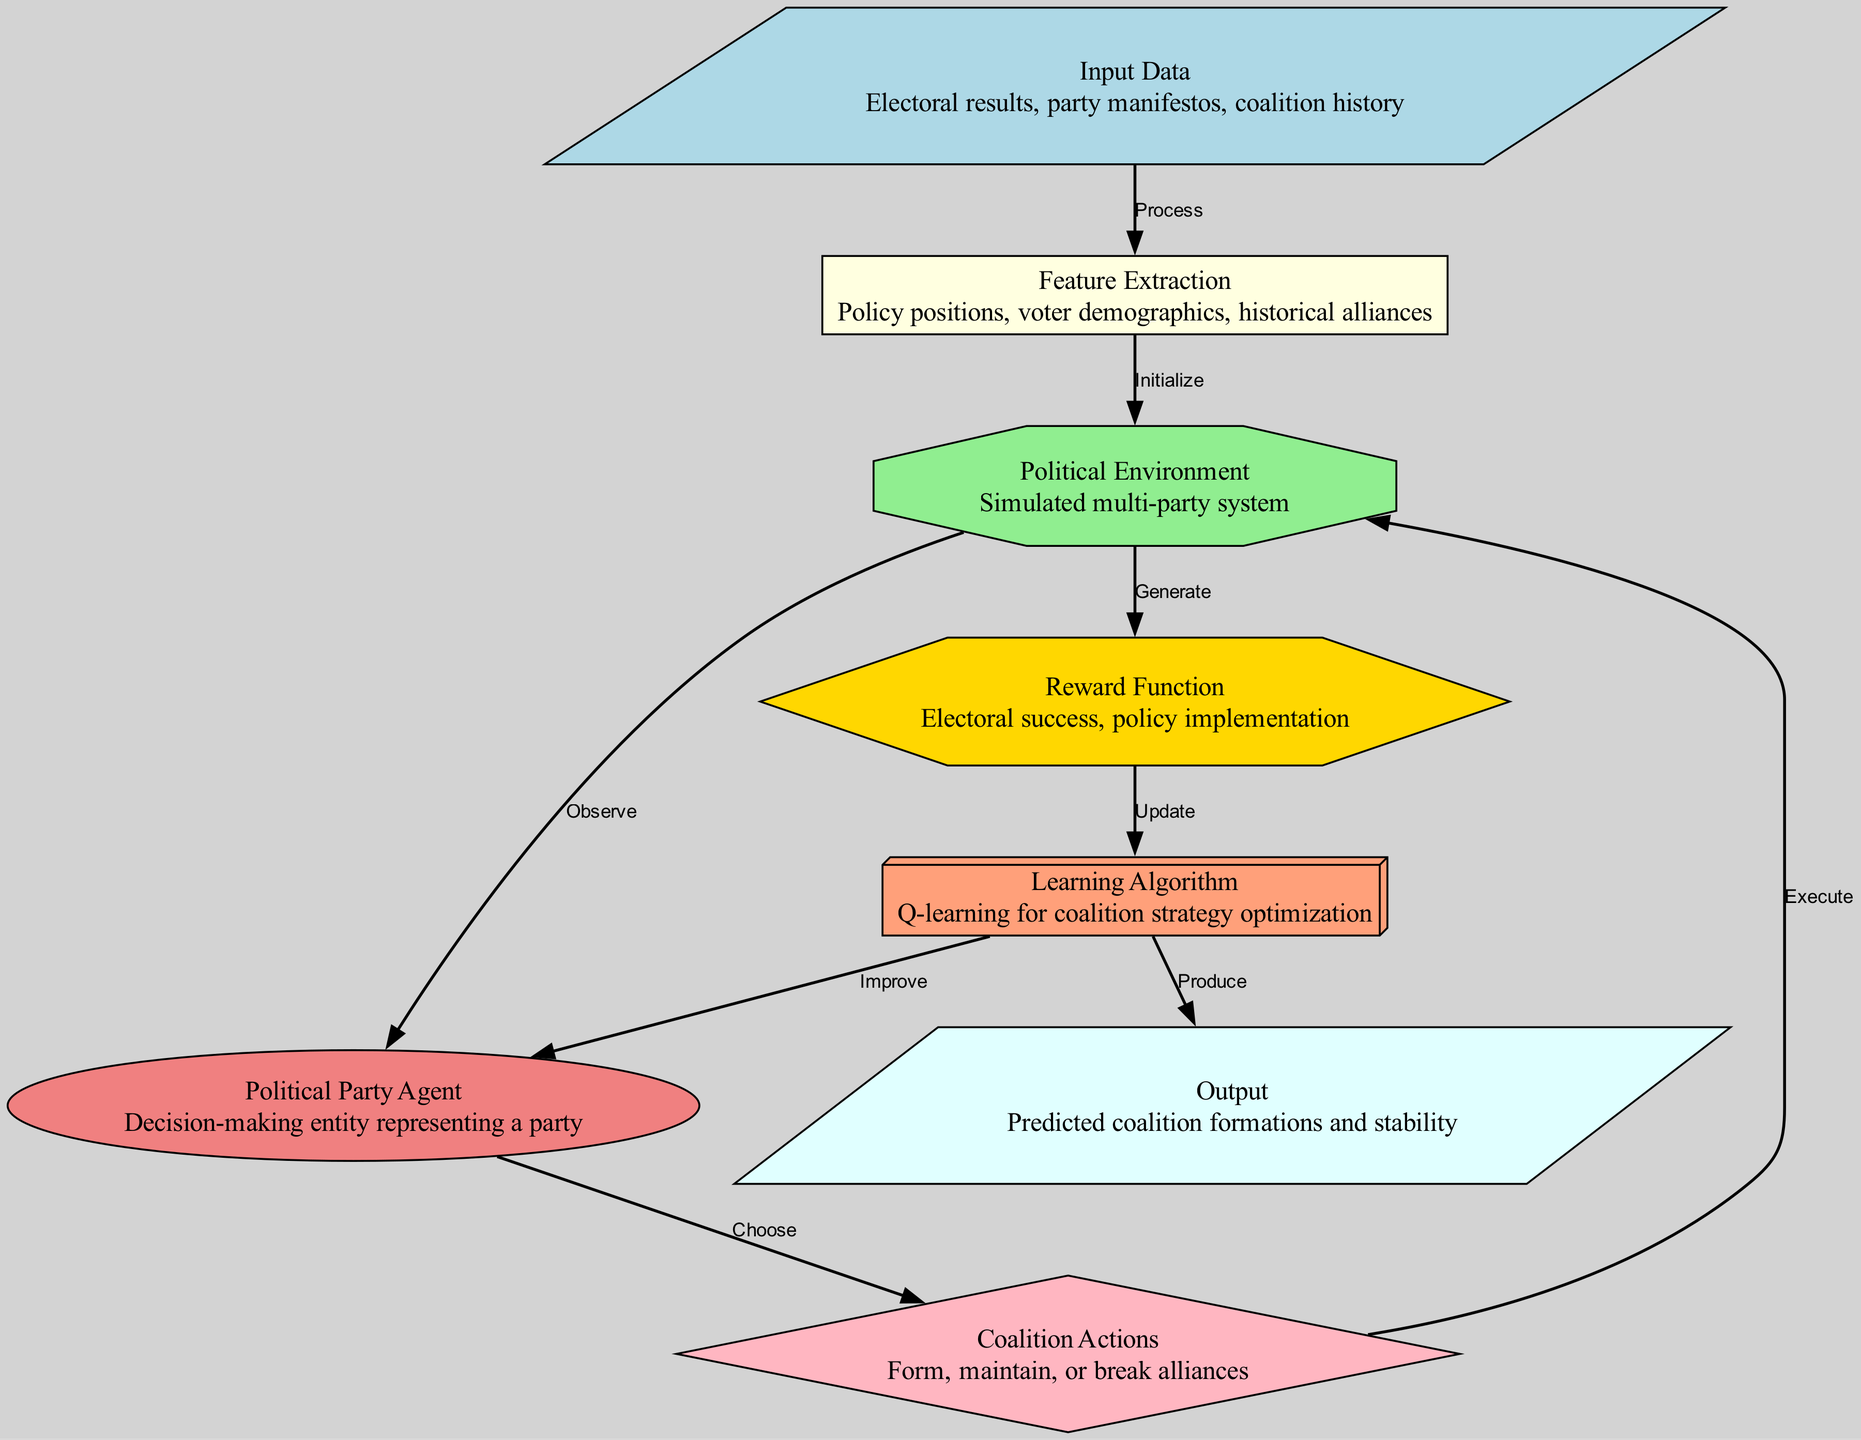What is the shape of the 'Input Data' node? The diagram specifies the 'Input Data' node as a parallelogram.
Answer: parallelogram How many total nodes are present in the diagram? There are eight nodes listed in the 'nodes' section of the data, which can be counted directly.
Answer: eight What relationship exists between the 'agent' and 'action' nodes? The 'agent' node chooses an action, as indicated by the edge labeled "Choose" connecting the two nodes.
Answer: Choose What does the 'Learning Algorithm' node produce? The 'Learning Algorithm' node produces the output, according to the directed edge labeled "Produce" connecting from 'learning' to 'output'.
Answer: Predicted coalition formations and stability In which node does the 'Reward Function' generate its output? The 'Reward Function' generates its output and is connected to the 'environment' node, as indicated by the edge labeled "Generate".
Answer: environment How does the 'feature extraction' relate to the 'Political Environment'? The 'feature extraction' node initializes the 'Political Environment', as shown by the edge labeled "Initialize" connecting these two nodes.
Answer: Initialize What action can a 'Political Party Agent' take? The 'Political Party Agent' can choose coalition actions, as explicitly indicated by the edge labeled "Choose" leading to the 'action' node.
Answer: Coalition Actions What function follows after the reward is generated? The reward function is utilized to update the learning algorithm, as indicated by the edge labeled "Update" flowing from 'reward' to 'learning'.
Answer: Update 